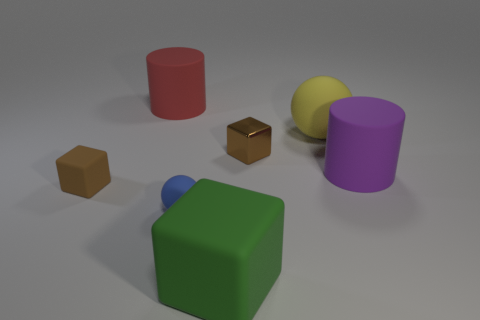Subtract all cyan spheres. Subtract all yellow cylinders. How many spheres are left? 2 Add 1 blue matte things. How many objects exist? 8 Subtract all blocks. How many objects are left? 4 Subtract 0 purple cubes. How many objects are left? 7 Subtract all large purple rubber cylinders. Subtract all purple things. How many objects are left? 5 Add 1 big purple things. How many big purple things are left? 2 Add 6 big purple metallic balls. How many big purple metallic balls exist? 6 